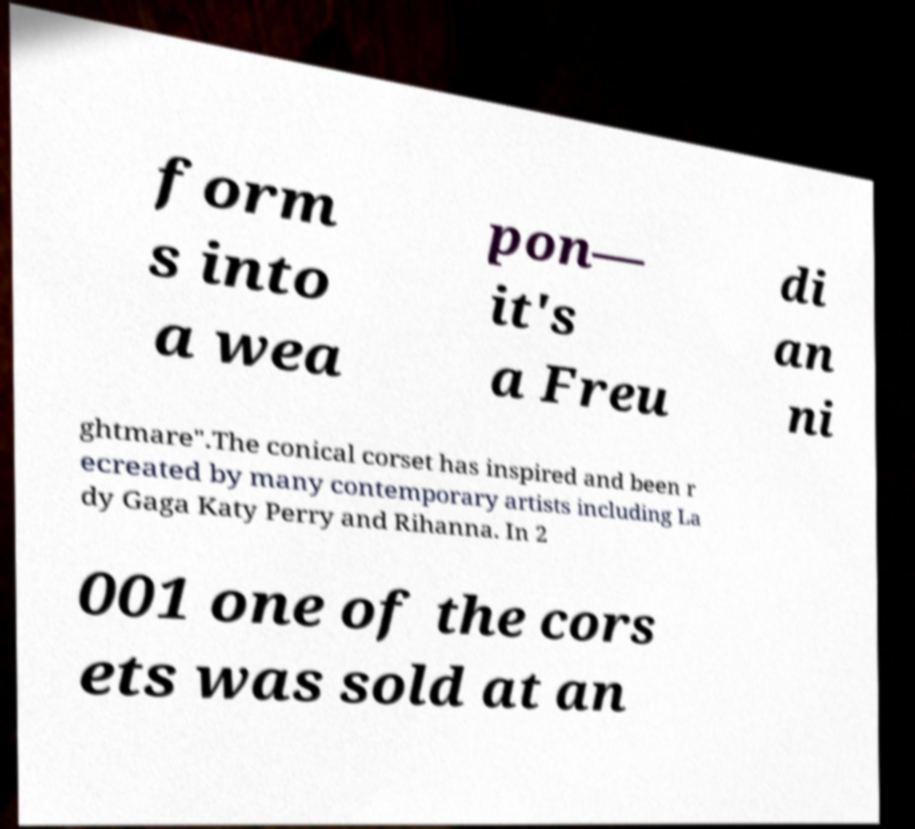Can you accurately transcribe the text from the provided image for me? form s into a wea pon— it's a Freu di an ni ghtmare".The conical corset has inspired and been r ecreated by many contemporary artists including La dy Gaga Katy Perry and Rihanna. In 2 001 one of the cors ets was sold at an 